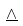Convert formula to latex. <formula><loc_0><loc_0><loc_500><loc_500>\underline { \wedge }</formula> 